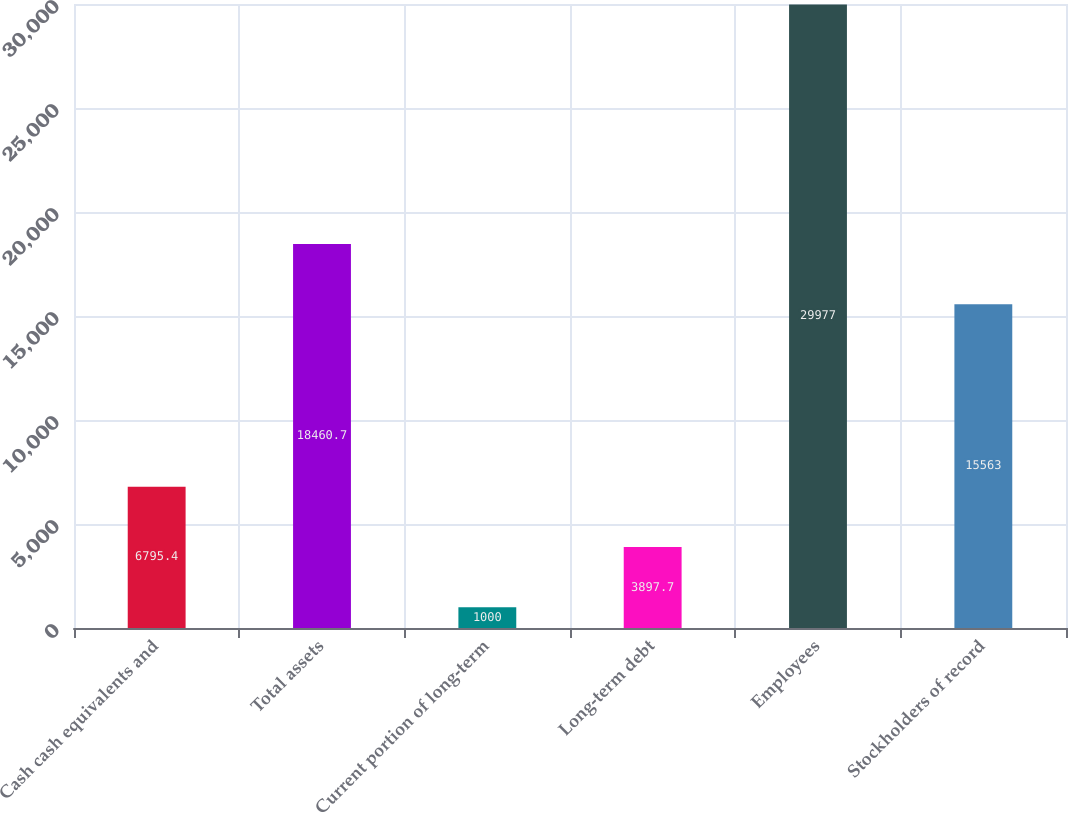Convert chart to OTSL. <chart><loc_0><loc_0><loc_500><loc_500><bar_chart><fcel>Cash cash equivalents and<fcel>Total assets<fcel>Current portion of long-term<fcel>Long-term debt<fcel>Employees<fcel>Stockholders of record<nl><fcel>6795.4<fcel>18460.7<fcel>1000<fcel>3897.7<fcel>29977<fcel>15563<nl></chart> 